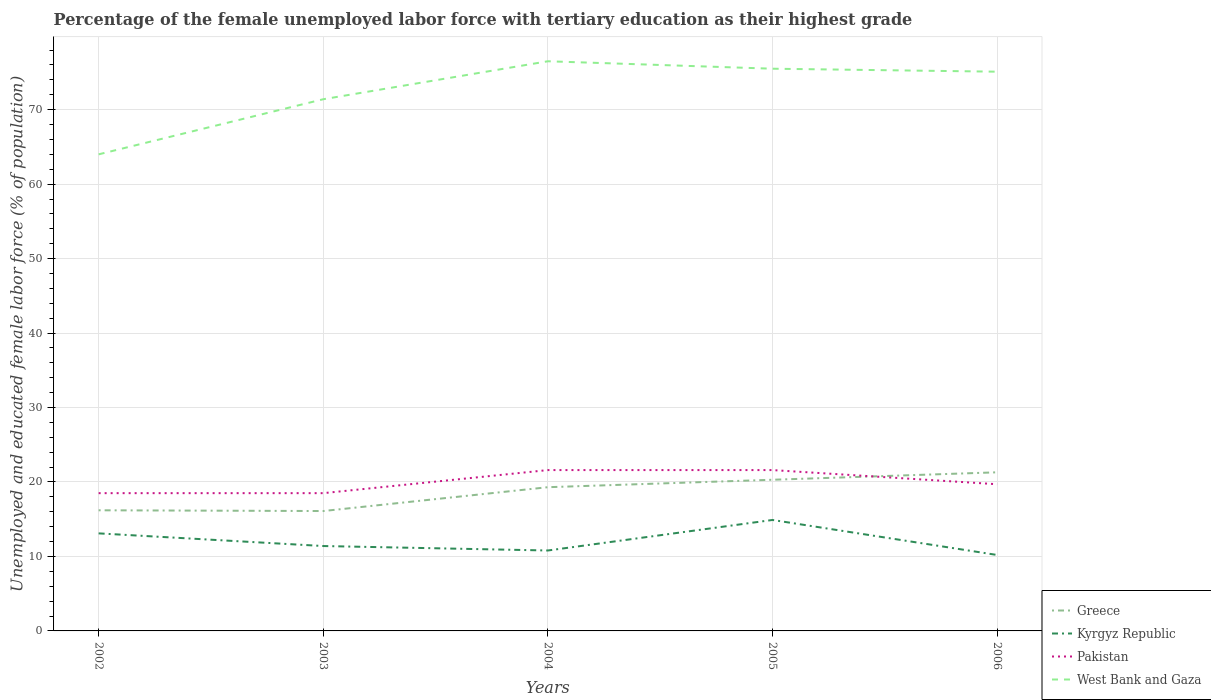Across all years, what is the maximum percentage of the unemployed female labor force with tertiary education in Greece?
Provide a short and direct response. 16.1. In which year was the percentage of the unemployed female labor force with tertiary education in Greece maximum?
Your answer should be very brief. 2003. What is the total percentage of the unemployed female labor force with tertiary education in Kyrgyz Republic in the graph?
Offer a very short reply. 2.9. What is the difference between the highest and the second highest percentage of the unemployed female labor force with tertiary education in Greece?
Make the answer very short. 5.2. Is the percentage of the unemployed female labor force with tertiary education in Kyrgyz Republic strictly greater than the percentage of the unemployed female labor force with tertiary education in West Bank and Gaza over the years?
Your answer should be compact. Yes. How many lines are there?
Ensure brevity in your answer.  4. How many years are there in the graph?
Offer a terse response. 5. What is the difference between two consecutive major ticks on the Y-axis?
Your answer should be compact. 10. Does the graph contain any zero values?
Your response must be concise. No. Does the graph contain grids?
Provide a succinct answer. Yes. How many legend labels are there?
Your response must be concise. 4. How are the legend labels stacked?
Provide a short and direct response. Vertical. What is the title of the graph?
Your answer should be very brief. Percentage of the female unemployed labor force with tertiary education as their highest grade. What is the label or title of the Y-axis?
Your answer should be very brief. Unemployed and educated female labor force (% of population). What is the Unemployed and educated female labor force (% of population) of Greece in 2002?
Provide a short and direct response. 16.2. What is the Unemployed and educated female labor force (% of population) of Kyrgyz Republic in 2002?
Ensure brevity in your answer.  13.1. What is the Unemployed and educated female labor force (% of population) in Greece in 2003?
Ensure brevity in your answer.  16.1. What is the Unemployed and educated female labor force (% of population) in Kyrgyz Republic in 2003?
Provide a succinct answer. 11.4. What is the Unemployed and educated female labor force (% of population) in West Bank and Gaza in 2003?
Offer a very short reply. 71.4. What is the Unemployed and educated female labor force (% of population) in Greece in 2004?
Keep it short and to the point. 19.3. What is the Unemployed and educated female labor force (% of population) in Kyrgyz Republic in 2004?
Ensure brevity in your answer.  10.8. What is the Unemployed and educated female labor force (% of population) of Pakistan in 2004?
Keep it short and to the point. 21.6. What is the Unemployed and educated female labor force (% of population) of West Bank and Gaza in 2004?
Keep it short and to the point. 76.5. What is the Unemployed and educated female labor force (% of population) of Greece in 2005?
Offer a very short reply. 20.3. What is the Unemployed and educated female labor force (% of population) of Kyrgyz Republic in 2005?
Keep it short and to the point. 14.9. What is the Unemployed and educated female labor force (% of population) of Pakistan in 2005?
Your answer should be very brief. 21.6. What is the Unemployed and educated female labor force (% of population) of West Bank and Gaza in 2005?
Keep it short and to the point. 75.5. What is the Unemployed and educated female labor force (% of population) of Greece in 2006?
Ensure brevity in your answer.  21.3. What is the Unemployed and educated female labor force (% of population) of Kyrgyz Republic in 2006?
Offer a terse response. 10.2. What is the Unemployed and educated female labor force (% of population) of Pakistan in 2006?
Provide a short and direct response. 19.7. What is the Unemployed and educated female labor force (% of population) in West Bank and Gaza in 2006?
Your response must be concise. 75.1. Across all years, what is the maximum Unemployed and educated female labor force (% of population) in Greece?
Your response must be concise. 21.3. Across all years, what is the maximum Unemployed and educated female labor force (% of population) of Kyrgyz Republic?
Provide a short and direct response. 14.9. Across all years, what is the maximum Unemployed and educated female labor force (% of population) in Pakistan?
Your answer should be very brief. 21.6. Across all years, what is the maximum Unemployed and educated female labor force (% of population) in West Bank and Gaza?
Offer a very short reply. 76.5. Across all years, what is the minimum Unemployed and educated female labor force (% of population) in Greece?
Offer a very short reply. 16.1. Across all years, what is the minimum Unemployed and educated female labor force (% of population) in Kyrgyz Republic?
Give a very brief answer. 10.2. Across all years, what is the minimum Unemployed and educated female labor force (% of population) of Pakistan?
Make the answer very short. 18.5. Across all years, what is the minimum Unemployed and educated female labor force (% of population) in West Bank and Gaza?
Make the answer very short. 64. What is the total Unemployed and educated female labor force (% of population) in Greece in the graph?
Ensure brevity in your answer.  93.2. What is the total Unemployed and educated female labor force (% of population) in Kyrgyz Republic in the graph?
Your answer should be very brief. 60.4. What is the total Unemployed and educated female labor force (% of population) of Pakistan in the graph?
Offer a terse response. 99.9. What is the total Unemployed and educated female labor force (% of population) in West Bank and Gaza in the graph?
Give a very brief answer. 362.5. What is the difference between the Unemployed and educated female labor force (% of population) of Greece in 2002 and that in 2003?
Your answer should be compact. 0.1. What is the difference between the Unemployed and educated female labor force (% of population) of Kyrgyz Republic in 2002 and that in 2003?
Keep it short and to the point. 1.7. What is the difference between the Unemployed and educated female labor force (% of population) of Pakistan in 2002 and that in 2003?
Ensure brevity in your answer.  0. What is the difference between the Unemployed and educated female labor force (% of population) in Kyrgyz Republic in 2002 and that in 2004?
Your answer should be compact. 2.3. What is the difference between the Unemployed and educated female labor force (% of population) of Pakistan in 2002 and that in 2004?
Make the answer very short. -3.1. What is the difference between the Unemployed and educated female labor force (% of population) of Greece in 2002 and that in 2005?
Ensure brevity in your answer.  -4.1. What is the difference between the Unemployed and educated female labor force (% of population) in Kyrgyz Republic in 2002 and that in 2005?
Offer a terse response. -1.8. What is the difference between the Unemployed and educated female labor force (% of population) of Pakistan in 2002 and that in 2005?
Your answer should be compact. -3.1. What is the difference between the Unemployed and educated female labor force (% of population) in West Bank and Gaza in 2002 and that in 2005?
Provide a succinct answer. -11.5. What is the difference between the Unemployed and educated female labor force (% of population) of Greece in 2002 and that in 2006?
Keep it short and to the point. -5.1. What is the difference between the Unemployed and educated female labor force (% of population) in Kyrgyz Republic in 2002 and that in 2006?
Offer a very short reply. 2.9. What is the difference between the Unemployed and educated female labor force (% of population) of West Bank and Gaza in 2002 and that in 2006?
Keep it short and to the point. -11.1. What is the difference between the Unemployed and educated female labor force (% of population) in Greece in 2003 and that in 2005?
Keep it short and to the point. -4.2. What is the difference between the Unemployed and educated female labor force (% of population) in Kyrgyz Republic in 2003 and that in 2005?
Offer a very short reply. -3.5. What is the difference between the Unemployed and educated female labor force (% of population) in Pakistan in 2003 and that in 2005?
Your response must be concise. -3.1. What is the difference between the Unemployed and educated female labor force (% of population) in Kyrgyz Republic in 2003 and that in 2006?
Keep it short and to the point. 1.2. What is the difference between the Unemployed and educated female labor force (% of population) of West Bank and Gaza in 2003 and that in 2006?
Ensure brevity in your answer.  -3.7. What is the difference between the Unemployed and educated female labor force (% of population) in Greece in 2004 and that in 2005?
Your response must be concise. -1. What is the difference between the Unemployed and educated female labor force (% of population) in West Bank and Gaza in 2004 and that in 2005?
Provide a short and direct response. 1. What is the difference between the Unemployed and educated female labor force (% of population) of Greece in 2004 and that in 2006?
Your answer should be compact. -2. What is the difference between the Unemployed and educated female labor force (% of population) of Kyrgyz Republic in 2004 and that in 2006?
Your answer should be compact. 0.6. What is the difference between the Unemployed and educated female labor force (% of population) of Pakistan in 2004 and that in 2006?
Your answer should be compact. 1.9. What is the difference between the Unemployed and educated female labor force (% of population) in West Bank and Gaza in 2004 and that in 2006?
Ensure brevity in your answer.  1.4. What is the difference between the Unemployed and educated female labor force (% of population) in Greece in 2005 and that in 2006?
Offer a terse response. -1. What is the difference between the Unemployed and educated female labor force (% of population) of Greece in 2002 and the Unemployed and educated female labor force (% of population) of West Bank and Gaza in 2003?
Ensure brevity in your answer.  -55.2. What is the difference between the Unemployed and educated female labor force (% of population) of Kyrgyz Republic in 2002 and the Unemployed and educated female labor force (% of population) of West Bank and Gaza in 2003?
Give a very brief answer. -58.3. What is the difference between the Unemployed and educated female labor force (% of population) of Pakistan in 2002 and the Unemployed and educated female labor force (% of population) of West Bank and Gaza in 2003?
Make the answer very short. -52.9. What is the difference between the Unemployed and educated female labor force (% of population) in Greece in 2002 and the Unemployed and educated female labor force (% of population) in West Bank and Gaza in 2004?
Give a very brief answer. -60.3. What is the difference between the Unemployed and educated female labor force (% of population) of Kyrgyz Republic in 2002 and the Unemployed and educated female labor force (% of population) of Pakistan in 2004?
Provide a succinct answer. -8.5. What is the difference between the Unemployed and educated female labor force (% of population) of Kyrgyz Republic in 2002 and the Unemployed and educated female labor force (% of population) of West Bank and Gaza in 2004?
Provide a succinct answer. -63.4. What is the difference between the Unemployed and educated female labor force (% of population) in Pakistan in 2002 and the Unemployed and educated female labor force (% of population) in West Bank and Gaza in 2004?
Keep it short and to the point. -58. What is the difference between the Unemployed and educated female labor force (% of population) in Greece in 2002 and the Unemployed and educated female labor force (% of population) in Kyrgyz Republic in 2005?
Offer a terse response. 1.3. What is the difference between the Unemployed and educated female labor force (% of population) in Greece in 2002 and the Unemployed and educated female labor force (% of population) in West Bank and Gaza in 2005?
Your response must be concise. -59.3. What is the difference between the Unemployed and educated female labor force (% of population) of Kyrgyz Republic in 2002 and the Unemployed and educated female labor force (% of population) of Pakistan in 2005?
Keep it short and to the point. -8.5. What is the difference between the Unemployed and educated female labor force (% of population) in Kyrgyz Republic in 2002 and the Unemployed and educated female labor force (% of population) in West Bank and Gaza in 2005?
Give a very brief answer. -62.4. What is the difference between the Unemployed and educated female labor force (% of population) in Pakistan in 2002 and the Unemployed and educated female labor force (% of population) in West Bank and Gaza in 2005?
Offer a terse response. -57. What is the difference between the Unemployed and educated female labor force (% of population) in Greece in 2002 and the Unemployed and educated female labor force (% of population) in West Bank and Gaza in 2006?
Make the answer very short. -58.9. What is the difference between the Unemployed and educated female labor force (% of population) of Kyrgyz Republic in 2002 and the Unemployed and educated female labor force (% of population) of West Bank and Gaza in 2006?
Keep it short and to the point. -62. What is the difference between the Unemployed and educated female labor force (% of population) in Pakistan in 2002 and the Unemployed and educated female labor force (% of population) in West Bank and Gaza in 2006?
Make the answer very short. -56.6. What is the difference between the Unemployed and educated female labor force (% of population) in Greece in 2003 and the Unemployed and educated female labor force (% of population) in Pakistan in 2004?
Your answer should be compact. -5.5. What is the difference between the Unemployed and educated female labor force (% of population) in Greece in 2003 and the Unemployed and educated female labor force (% of population) in West Bank and Gaza in 2004?
Keep it short and to the point. -60.4. What is the difference between the Unemployed and educated female labor force (% of population) of Kyrgyz Republic in 2003 and the Unemployed and educated female labor force (% of population) of Pakistan in 2004?
Give a very brief answer. -10.2. What is the difference between the Unemployed and educated female labor force (% of population) of Kyrgyz Republic in 2003 and the Unemployed and educated female labor force (% of population) of West Bank and Gaza in 2004?
Your answer should be very brief. -65.1. What is the difference between the Unemployed and educated female labor force (% of population) in Pakistan in 2003 and the Unemployed and educated female labor force (% of population) in West Bank and Gaza in 2004?
Provide a succinct answer. -58. What is the difference between the Unemployed and educated female labor force (% of population) in Greece in 2003 and the Unemployed and educated female labor force (% of population) in Kyrgyz Republic in 2005?
Provide a succinct answer. 1.2. What is the difference between the Unemployed and educated female labor force (% of population) in Greece in 2003 and the Unemployed and educated female labor force (% of population) in Pakistan in 2005?
Your response must be concise. -5.5. What is the difference between the Unemployed and educated female labor force (% of population) in Greece in 2003 and the Unemployed and educated female labor force (% of population) in West Bank and Gaza in 2005?
Give a very brief answer. -59.4. What is the difference between the Unemployed and educated female labor force (% of population) in Kyrgyz Republic in 2003 and the Unemployed and educated female labor force (% of population) in West Bank and Gaza in 2005?
Offer a terse response. -64.1. What is the difference between the Unemployed and educated female labor force (% of population) in Pakistan in 2003 and the Unemployed and educated female labor force (% of population) in West Bank and Gaza in 2005?
Provide a short and direct response. -57. What is the difference between the Unemployed and educated female labor force (% of population) of Greece in 2003 and the Unemployed and educated female labor force (% of population) of Kyrgyz Republic in 2006?
Your answer should be compact. 5.9. What is the difference between the Unemployed and educated female labor force (% of population) of Greece in 2003 and the Unemployed and educated female labor force (% of population) of Pakistan in 2006?
Make the answer very short. -3.6. What is the difference between the Unemployed and educated female labor force (% of population) of Greece in 2003 and the Unemployed and educated female labor force (% of population) of West Bank and Gaza in 2006?
Your answer should be compact. -59. What is the difference between the Unemployed and educated female labor force (% of population) in Kyrgyz Republic in 2003 and the Unemployed and educated female labor force (% of population) in Pakistan in 2006?
Provide a short and direct response. -8.3. What is the difference between the Unemployed and educated female labor force (% of population) in Kyrgyz Republic in 2003 and the Unemployed and educated female labor force (% of population) in West Bank and Gaza in 2006?
Offer a very short reply. -63.7. What is the difference between the Unemployed and educated female labor force (% of population) in Pakistan in 2003 and the Unemployed and educated female labor force (% of population) in West Bank and Gaza in 2006?
Provide a succinct answer. -56.6. What is the difference between the Unemployed and educated female labor force (% of population) in Greece in 2004 and the Unemployed and educated female labor force (% of population) in Kyrgyz Republic in 2005?
Provide a succinct answer. 4.4. What is the difference between the Unemployed and educated female labor force (% of population) of Greece in 2004 and the Unemployed and educated female labor force (% of population) of Pakistan in 2005?
Your answer should be compact. -2.3. What is the difference between the Unemployed and educated female labor force (% of population) in Greece in 2004 and the Unemployed and educated female labor force (% of population) in West Bank and Gaza in 2005?
Offer a very short reply. -56.2. What is the difference between the Unemployed and educated female labor force (% of population) of Kyrgyz Republic in 2004 and the Unemployed and educated female labor force (% of population) of West Bank and Gaza in 2005?
Provide a succinct answer. -64.7. What is the difference between the Unemployed and educated female labor force (% of population) of Pakistan in 2004 and the Unemployed and educated female labor force (% of population) of West Bank and Gaza in 2005?
Provide a short and direct response. -53.9. What is the difference between the Unemployed and educated female labor force (% of population) of Greece in 2004 and the Unemployed and educated female labor force (% of population) of Pakistan in 2006?
Offer a very short reply. -0.4. What is the difference between the Unemployed and educated female labor force (% of population) of Greece in 2004 and the Unemployed and educated female labor force (% of population) of West Bank and Gaza in 2006?
Make the answer very short. -55.8. What is the difference between the Unemployed and educated female labor force (% of population) in Kyrgyz Republic in 2004 and the Unemployed and educated female labor force (% of population) in West Bank and Gaza in 2006?
Provide a short and direct response. -64.3. What is the difference between the Unemployed and educated female labor force (% of population) in Pakistan in 2004 and the Unemployed and educated female labor force (% of population) in West Bank and Gaza in 2006?
Your answer should be very brief. -53.5. What is the difference between the Unemployed and educated female labor force (% of population) of Greece in 2005 and the Unemployed and educated female labor force (% of population) of Kyrgyz Republic in 2006?
Give a very brief answer. 10.1. What is the difference between the Unemployed and educated female labor force (% of population) in Greece in 2005 and the Unemployed and educated female labor force (% of population) in West Bank and Gaza in 2006?
Make the answer very short. -54.8. What is the difference between the Unemployed and educated female labor force (% of population) in Kyrgyz Republic in 2005 and the Unemployed and educated female labor force (% of population) in Pakistan in 2006?
Your response must be concise. -4.8. What is the difference between the Unemployed and educated female labor force (% of population) of Kyrgyz Republic in 2005 and the Unemployed and educated female labor force (% of population) of West Bank and Gaza in 2006?
Provide a short and direct response. -60.2. What is the difference between the Unemployed and educated female labor force (% of population) of Pakistan in 2005 and the Unemployed and educated female labor force (% of population) of West Bank and Gaza in 2006?
Keep it short and to the point. -53.5. What is the average Unemployed and educated female labor force (% of population) in Greece per year?
Offer a very short reply. 18.64. What is the average Unemployed and educated female labor force (% of population) of Kyrgyz Republic per year?
Make the answer very short. 12.08. What is the average Unemployed and educated female labor force (% of population) in Pakistan per year?
Make the answer very short. 19.98. What is the average Unemployed and educated female labor force (% of population) in West Bank and Gaza per year?
Your answer should be compact. 72.5. In the year 2002, what is the difference between the Unemployed and educated female labor force (% of population) of Greece and Unemployed and educated female labor force (% of population) of West Bank and Gaza?
Give a very brief answer. -47.8. In the year 2002, what is the difference between the Unemployed and educated female labor force (% of population) of Kyrgyz Republic and Unemployed and educated female labor force (% of population) of Pakistan?
Keep it short and to the point. -5.4. In the year 2002, what is the difference between the Unemployed and educated female labor force (% of population) of Kyrgyz Republic and Unemployed and educated female labor force (% of population) of West Bank and Gaza?
Provide a short and direct response. -50.9. In the year 2002, what is the difference between the Unemployed and educated female labor force (% of population) of Pakistan and Unemployed and educated female labor force (% of population) of West Bank and Gaza?
Make the answer very short. -45.5. In the year 2003, what is the difference between the Unemployed and educated female labor force (% of population) in Greece and Unemployed and educated female labor force (% of population) in Kyrgyz Republic?
Keep it short and to the point. 4.7. In the year 2003, what is the difference between the Unemployed and educated female labor force (% of population) of Greece and Unemployed and educated female labor force (% of population) of West Bank and Gaza?
Make the answer very short. -55.3. In the year 2003, what is the difference between the Unemployed and educated female labor force (% of population) of Kyrgyz Republic and Unemployed and educated female labor force (% of population) of West Bank and Gaza?
Your answer should be very brief. -60. In the year 2003, what is the difference between the Unemployed and educated female labor force (% of population) of Pakistan and Unemployed and educated female labor force (% of population) of West Bank and Gaza?
Your answer should be very brief. -52.9. In the year 2004, what is the difference between the Unemployed and educated female labor force (% of population) in Greece and Unemployed and educated female labor force (% of population) in Pakistan?
Your answer should be very brief. -2.3. In the year 2004, what is the difference between the Unemployed and educated female labor force (% of population) of Greece and Unemployed and educated female labor force (% of population) of West Bank and Gaza?
Your answer should be compact. -57.2. In the year 2004, what is the difference between the Unemployed and educated female labor force (% of population) in Kyrgyz Republic and Unemployed and educated female labor force (% of population) in West Bank and Gaza?
Offer a very short reply. -65.7. In the year 2004, what is the difference between the Unemployed and educated female labor force (% of population) of Pakistan and Unemployed and educated female labor force (% of population) of West Bank and Gaza?
Give a very brief answer. -54.9. In the year 2005, what is the difference between the Unemployed and educated female labor force (% of population) in Greece and Unemployed and educated female labor force (% of population) in Pakistan?
Ensure brevity in your answer.  -1.3. In the year 2005, what is the difference between the Unemployed and educated female labor force (% of population) in Greece and Unemployed and educated female labor force (% of population) in West Bank and Gaza?
Provide a short and direct response. -55.2. In the year 2005, what is the difference between the Unemployed and educated female labor force (% of population) in Kyrgyz Republic and Unemployed and educated female labor force (% of population) in Pakistan?
Provide a succinct answer. -6.7. In the year 2005, what is the difference between the Unemployed and educated female labor force (% of population) in Kyrgyz Republic and Unemployed and educated female labor force (% of population) in West Bank and Gaza?
Give a very brief answer. -60.6. In the year 2005, what is the difference between the Unemployed and educated female labor force (% of population) of Pakistan and Unemployed and educated female labor force (% of population) of West Bank and Gaza?
Give a very brief answer. -53.9. In the year 2006, what is the difference between the Unemployed and educated female labor force (% of population) in Greece and Unemployed and educated female labor force (% of population) in Kyrgyz Republic?
Give a very brief answer. 11.1. In the year 2006, what is the difference between the Unemployed and educated female labor force (% of population) in Greece and Unemployed and educated female labor force (% of population) in West Bank and Gaza?
Give a very brief answer. -53.8. In the year 2006, what is the difference between the Unemployed and educated female labor force (% of population) of Kyrgyz Republic and Unemployed and educated female labor force (% of population) of West Bank and Gaza?
Offer a very short reply. -64.9. In the year 2006, what is the difference between the Unemployed and educated female labor force (% of population) of Pakistan and Unemployed and educated female labor force (% of population) of West Bank and Gaza?
Your answer should be compact. -55.4. What is the ratio of the Unemployed and educated female labor force (% of population) in Kyrgyz Republic in 2002 to that in 2003?
Your answer should be compact. 1.15. What is the ratio of the Unemployed and educated female labor force (% of population) of Pakistan in 2002 to that in 2003?
Provide a succinct answer. 1. What is the ratio of the Unemployed and educated female labor force (% of population) of West Bank and Gaza in 2002 to that in 2003?
Offer a very short reply. 0.9. What is the ratio of the Unemployed and educated female labor force (% of population) of Greece in 2002 to that in 2004?
Keep it short and to the point. 0.84. What is the ratio of the Unemployed and educated female labor force (% of population) of Kyrgyz Republic in 2002 to that in 2004?
Your response must be concise. 1.21. What is the ratio of the Unemployed and educated female labor force (% of population) in Pakistan in 2002 to that in 2004?
Keep it short and to the point. 0.86. What is the ratio of the Unemployed and educated female labor force (% of population) in West Bank and Gaza in 2002 to that in 2004?
Your response must be concise. 0.84. What is the ratio of the Unemployed and educated female labor force (% of population) of Greece in 2002 to that in 2005?
Your answer should be very brief. 0.8. What is the ratio of the Unemployed and educated female labor force (% of population) in Kyrgyz Republic in 2002 to that in 2005?
Ensure brevity in your answer.  0.88. What is the ratio of the Unemployed and educated female labor force (% of population) of Pakistan in 2002 to that in 2005?
Your answer should be very brief. 0.86. What is the ratio of the Unemployed and educated female labor force (% of population) in West Bank and Gaza in 2002 to that in 2005?
Provide a succinct answer. 0.85. What is the ratio of the Unemployed and educated female labor force (% of population) of Greece in 2002 to that in 2006?
Provide a short and direct response. 0.76. What is the ratio of the Unemployed and educated female labor force (% of population) in Kyrgyz Republic in 2002 to that in 2006?
Give a very brief answer. 1.28. What is the ratio of the Unemployed and educated female labor force (% of population) in Pakistan in 2002 to that in 2006?
Provide a short and direct response. 0.94. What is the ratio of the Unemployed and educated female labor force (% of population) of West Bank and Gaza in 2002 to that in 2006?
Offer a terse response. 0.85. What is the ratio of the Unemployed and educated female labor force (% of population) in Greece in 2003 to that in 2004?
Make the answer very short. 0.83. What is the ratio of the Unemployed and educated female labor force (% of population) in Kyrgyz Republic in 2003 to that in 2004?
Offer a very short reply. 1.06. What is the ratio of the Unemployed and educated female labor force (% of population) of Pakistan in 2003 to that in 2004?
Ensure brevity in your answer.  0.86. What is the ratio of the Unemployed and educated female labor force (% of population) of Greece in 2003 to that in 2005?
Provide a succinct answer. 0.79. What is the ratio of the Unemployed and educated female labor force (% of population) of Kyrgyz Republic in 2003 to that in 2005?
Offer a very short reply. 0.77. What is the ratio of the Unemployed and educated female labor force (% of population) of Pakistan in 2003 to that in 2005?
Your answer should be compact. 0.86. What is the ratio of the Unemployed and educated female labor force (% of population) in West Bank and Gaza in 2003 to that in 2005?
Your response must be concise. 0.95. What is the ratio of the Unemployed and educated female labor force (% of population) of Greece in 2003 to that in 2006?
Provide a succinct answer. 0.76. What is the ratio of the Unemployed and educated female labor force (% of population) in Kyrgyz Republic in 2003 to that in 2006?
Your response must be concise. 1.12. What is the ratio of the Unemployed and educated female labor force (% of population) of Pakistan in 2003 to that in 2006?
Keep it short and to the point. 0.94. What is the ratio of the Unemployed and educated female labor force (% of population) of West Bank and Gaza in 2003 to that in 2006?
Your answer should be very brief. 0.95. What is the ratio of the Unemployed and educated female labor force (% of population) of Greece in 2004 to that in 2005?
Give a very brief answer. 0.95. What is the ratio of the Unemployed and educated female labor force (% of population) in Kyrgyz Republic in 2004 to that in 2005?
Your response must be concise. 0.72. What is the ratio of the Unemployed and educated female labor force (% of population) in Pakistan in 2004 to that in 2005?
Give a very brief answer. 1. What is the ratio of the Unemployed and educated female labor force (% of population) in West Bank and Gaza in 2004 to that in 2005?
Ensure brevity in your answer.  1.01. What is the ratio of the Unemployed and educated female labor force (% of population) of Greece in 2004 to that in 2006?
Give a very brief answer. 0.91. What is the ratio of the Unemployed and educated female labor force (% of population) of Kyrgyz Republic in 2004 to that in 2006?
Keep it short and to the point. 1.06. What is the ratio of the Unemployed and educated female labor force (% of population) of Pakistan in 2004 to that in 2006?
Your response must be concise. 1.1. What is the ratio of the Unemployed and educated female labor force (% of population) of West Bank and Gaza in 2004 to that in 2006?
Your response must be concise. 1.02. What is the ratio of the Unemployed and educated female labor force (% of population) of Greece in 2005 to that in 2006?
Ensure brevity in your answer.  0.95. What is the ratio of the Unemployed and educated female labor force (% of population) in Kyrgyz Republic in 2005 to that in 2006?
Your response must be concise. 1.46. What is the ratio of the Unemployed and educated female labor force (% of population) in Pakistan in 2005 to that in 2006?
Your response must be concise. 1.1. What is the difference between the highest and the second highest Unemployed and educated female labor force (% of population) in Greece?
Keep it short and to the point. 1. What is the difference between the highest and the second highest Unemployed and educated female labor force (% of population) in Kyrgyz Republic?
Your answer should be compact. 1.8. What is the difference between the highest and the second highest Unemployed and educated female labor force (% of population) in Pakistan?
Your answer should be compact. 0. What is the difference between the highest and the second highest Unemployed and educated female labor force (% of population) of West Bank and Gaza?
Your answer should be very brief. 1. 